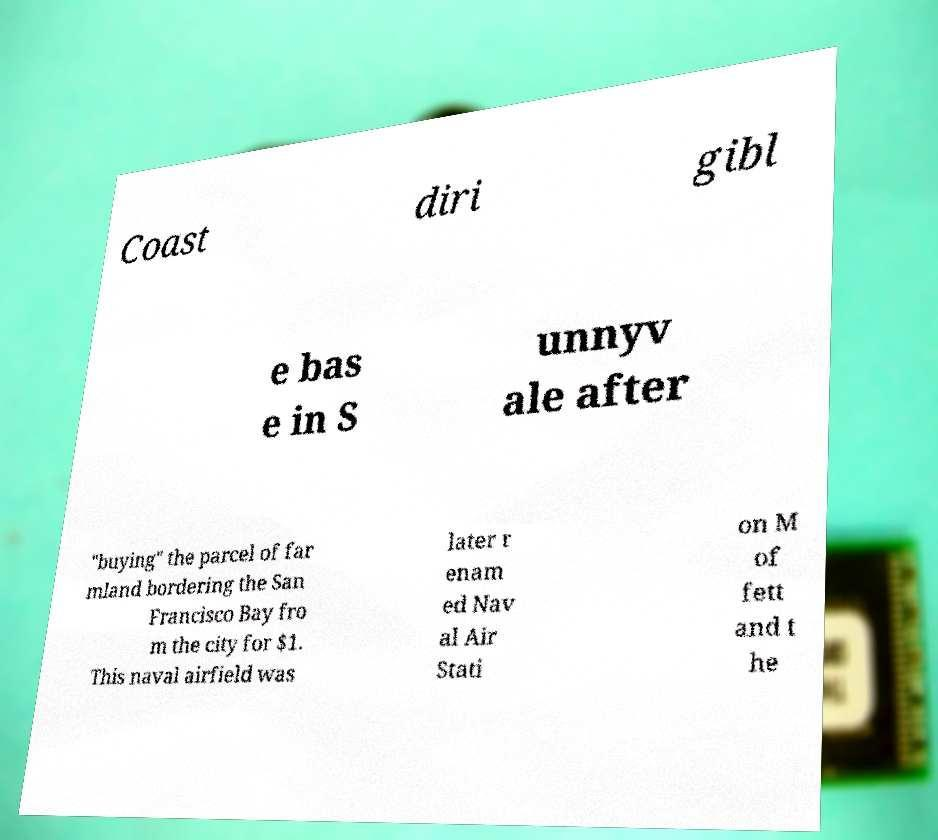There's text embedded in this image that I need extracted. Can you transcribe it verbatim? Coast diri gibl e bas e in S unnyv ale after "buying" the parcel of far mland bordering the San Francisco Bay fro m the city for $1. This naval airfield was later r enam ed Nav al Air Stati on M of fett and t he 